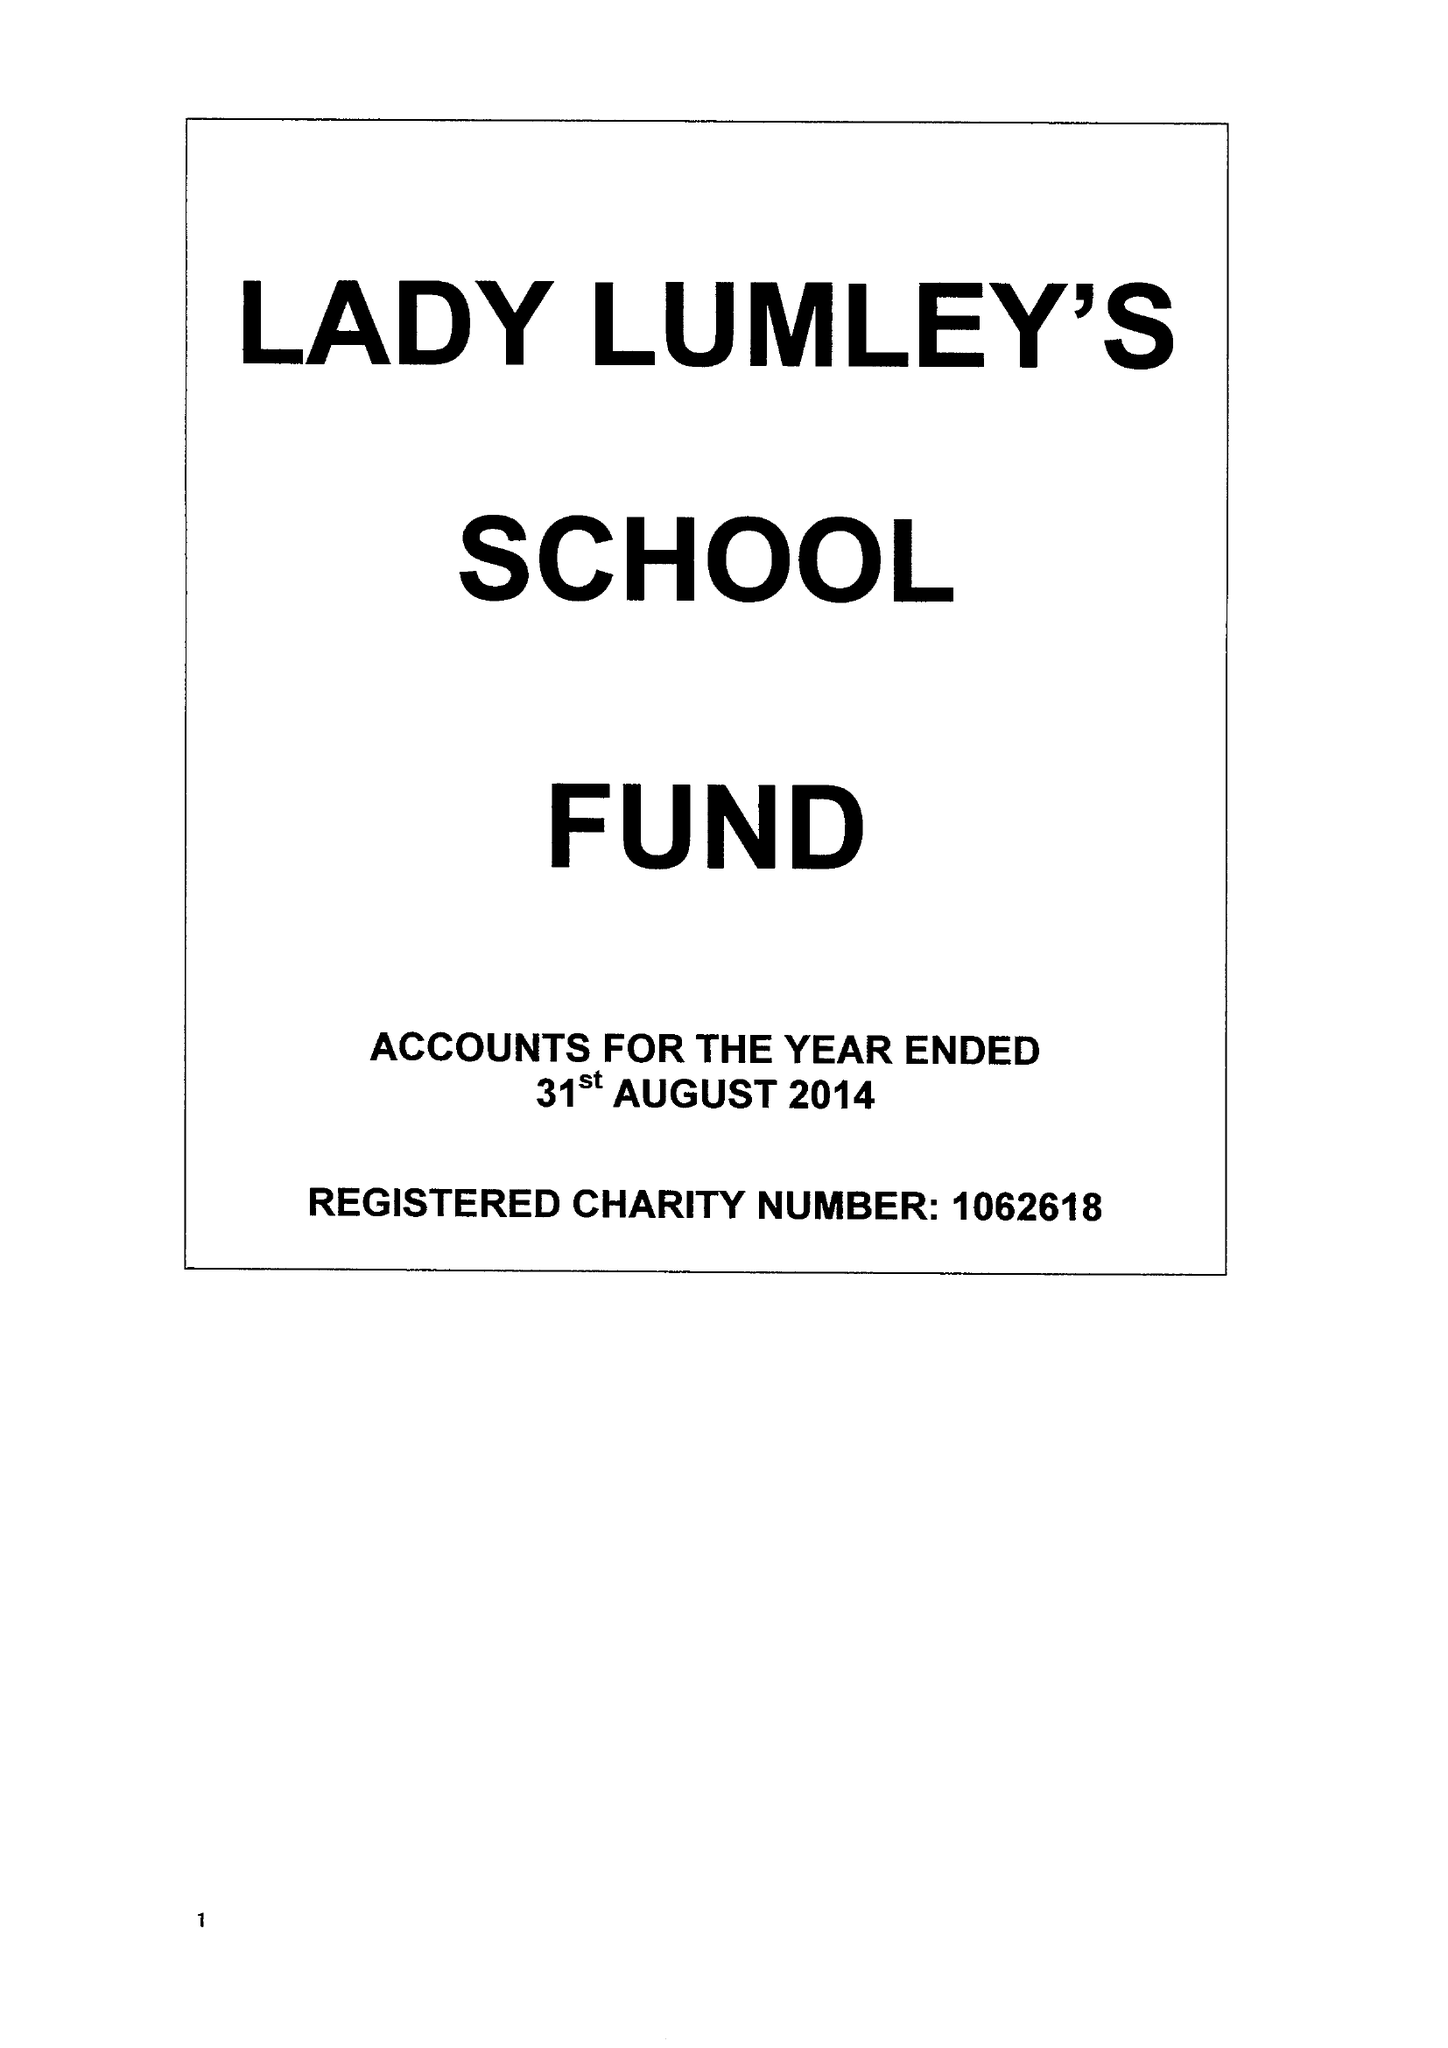What is the value for the charity_name?
Answer the question using a single word or phrase. Lady Lumley's School Fund 